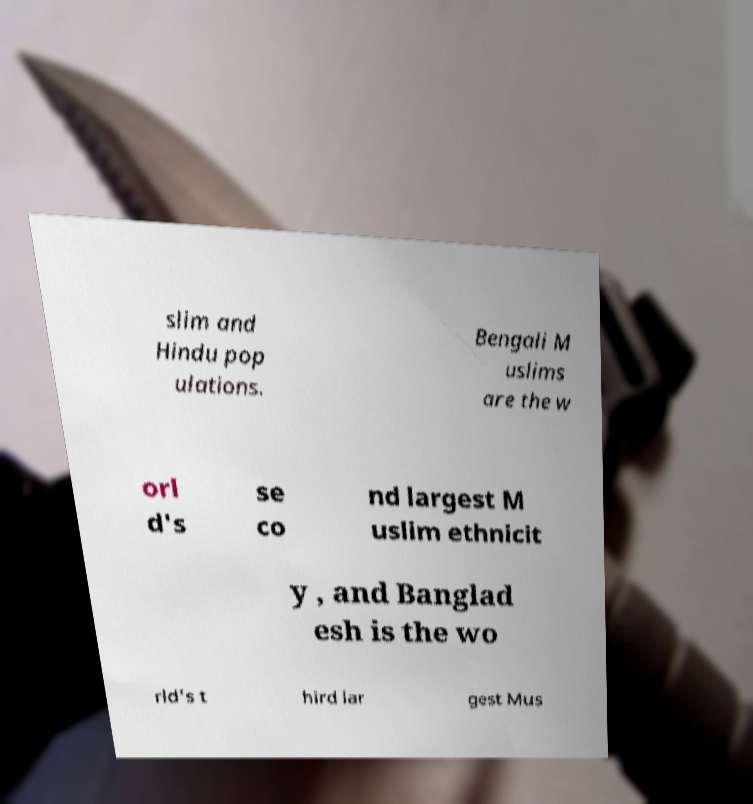Can you read and provide the text displayed in the image?This photo seems to have some interesting text. Can you extract and type it out for me? slim and Hindu pop ulations. Bengali M uslims are the w orl d's se co nd largest M uslim ethnicit y , and Banglad esh is the wo rld's t hird lar gest Mus 